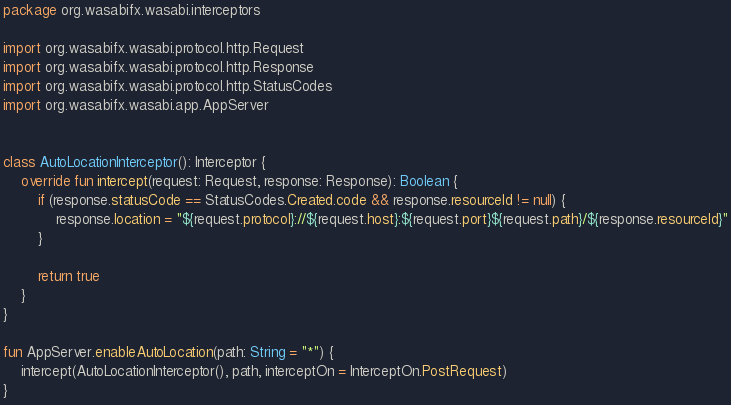<code> <loc_0><loc_0><loc_500><loc_500><_Kotlin_>package org.wasabifx.wasabi.interceptors

import org.wasabifx.wasabi.protocol.http.Request
import org.wasabifx.wasabi.protocol.http.Response
import org.wasabifx.wasabi.protocol.http.StatusCodes
import org.wasabifx.wasabi.app.AppServer


class AutoLocationInterceptor(): Interceptor {
    override fun intercept(request: Request, response: Response): Boolean {
        if (response.statusCode == StatusCodes.Created.code && response.resourceId != null) {
            response.location = "${request.protocol}://${request.host}:${request.port}${request.path}/${response.resourceId}"
        }

        return true
    }
}

fun AppServer.enableAutoLocation(path: String = "*") {
    intercept(AutoLocationInterceptor(), path, interceptOn = InterceptOn.PostRequest)
}</code> 